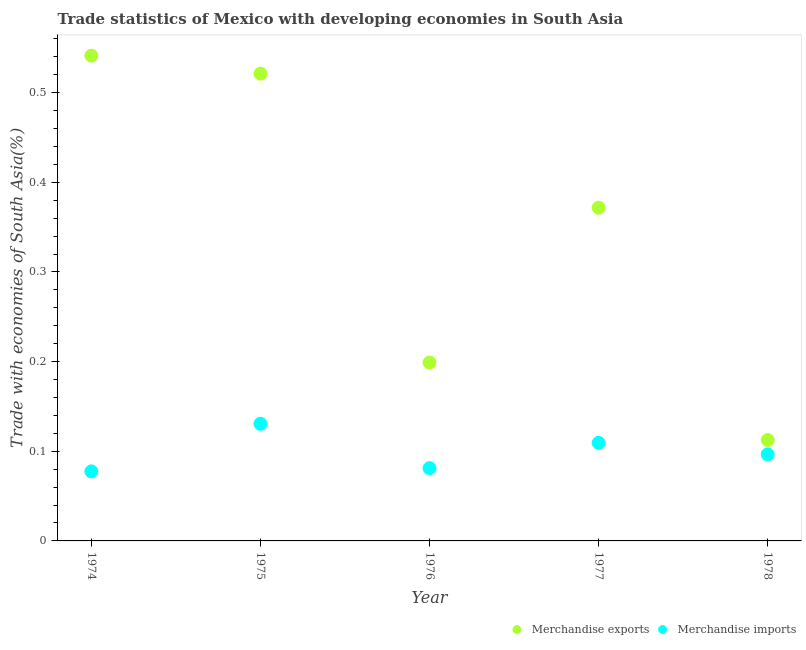How many different coloured dotlines are there?
Provide a succinct answer. 2. Is the number of dotlines equal to the number of legend labels?
Give a very brief answer. Yes. What is the merchandise exports in 1975?
Give a very brief answer. 0.52. Across all years, what is the maximum merchandise exports?
Provide a short and direct response. 0.54. Across all years, what is the minimum merchandise exports?
Provide a succinct answer. 0.11. In which year was the merchandise imports maximum?
Provide a succinct answer. 1975. In which year was the merchandise exports minimum?
Provide a short and direct response. 1978. What is the total merchandise imports in the graph?
Offer a terse response. 0.5. What is the difference between the merchandise exports in 1975 and that in 1977?
Ensure brevity in your answer.  0.15. What is the difference between the merchandise imports in 1978 and the merchandise exports in 1977?
Your answer should be compact. -0.28. What is the average merchandise imports per year?
Make the answer very short. 0.1. In the year 1974, what is the difference between the merchandise exports and merchandise imports?
Offer a terse response. 0.46. What is the ratio of the merchandise imports in 1974 to that in 1977?
Offer a very short reply. 0.71. Is the difference between the merchandise imports in 1974 and 1978 greater than the difference between the merchandise exports in 1974 and 1978?
Your response must be concise. No. What is the difference between the highest and the second highest merchandise imports?
Your answer should be very brief. 0.02. What is the difference between the highest and the lowest merchandise exports?
Provide a short and direct response. 0.43. In how many years, is the merchandise exports greater than the average merchandise exports taken over all years?
Keep it short and to the point. 3. Is the merchandise imports strictly less than the merchandise exports over the years?
Give a very brief answer. Yes. How many dotlines are there?
Make the answer very short. 2. What is the difference between two consecutive major ticks on the Y-axis?
Offer a terse response. 0.1. Does the graph contain any zero values?
Keep it short and to the point. No. Where does the legend appear in the graph?
Offer a very short reply. Bottom right. How are the legend labels stacked?
Your answer should be very brief. Horizontal. What is the title of the graph?
Provide a succinct answer. Trade statistics of Mexico with developing economies in South Asia. What is the label or title of the X-axis?
Keep it short and to the point. Year. What is the label or title of the Y-axis?
Offer a terse response. Trade with economies of South Asia(%). What is the Trade with economies of South Asia(%) in Merchandise exports in 1974?
Make the answer very short. 0.54. What is the Trade with economies of South Asia(%) of Merchandise imports in 1974?
Provide a short and direct response. 0.08. What is the Trade with economies of South Asia(%) in Merchandise exports in 1975?
Give a very brief answer. 0.52. What is the Trade with economies of South Asia(%) in Merchandise imports in 1975?
Keep it short and to the point. 0.13. What is the Trade with economies of South Asia(%) of Merchandise exports in 1976?
Provide a short and direct response. 0.2. What is the Trade with economies of South Asia(%) of Merchandise imports in 1976?
Provide a short and direct response. 0.08. What is the Trade with economies of South Asia(%) in Merchandise exports in 1977?
Provide a short and direct response. 0.37. What is the Trade with economies of South Asia(%) of Merchandise imports in 1977?
Ensure brevity in your answer.  0.11. What is the Trade with economies of South Asia(%) of Merchandise exports in 1978?
Provide a succinct answer. 0.11. What is the Trade with economies of South Asia(%) in Merchandise imports in 1978?
Make the answer very short. 0.1. Across all years, what is the maximum Trade with economies of South Asia(%) in Merchandise exports?
Your response must be concise. 0.54. Across all years, what is the maximum Trade with economies of South Asia(%) of Merchandise imports?
Offer a terse response. 0.13. Across all years, what is the minimum Trade with economies of South Asia(%) in Merchandise exports?
Your response must be concise. 0.11. Across all years, what is the minimum Trade with economies of South Asia(%) of Merchandise imports?
Your response must be concise. 0.08. What is the total Trade with economies of South Asia(%) in Merchandise exports in the graph?
Your answer should be very brief. 1.75. What is the total Trade with economies of South Asia(%) in Merchandise imports in the graph?
Provide a succinct answer. 0.5. What is the difference between the Trade with economies of South Asia(%) of Merchandise exports in 1974 and that in 1975?
Your response must be concise. 0.02. What is the difference between the Trade with economies of South Asia(%) of Merchandise imports in 1974 and that in 1975?
Ensure brevity in your answer.  -0.05. What is the difference between the Trade with economies of South Asia(%) in Merchandise exports in 1974 and that in 1976?
Offer a terse response. 0.34. What is the difference between the Trade with economies of South Asia(%) of Merchandise imports in 1974 and that in 1976?
Your answer should be very brief. -0. What is the difference between the Trade with economies of South Asia(%) in Merchandise exports in 1974 and that in 1977?
Make the answer very short. 0.17. What is the difference between the Trade with economies of South Asia(%) of Merchandise imports in 1974 and that in 1977?
Keep it short and to the point. -0.03. What is the difference between the Trade with economies of South Asia(%) in Merchandise exports in 1974 and that in 1978?
Keep it short and to the point. 0.43. What is the difference between the Trade with economies of South Asia(%) in Merchandise imports in 1974 and that in 1978?
Make the answer very short. -0.02. What is the difference between the Trade with economies of South Asia(%) of Merchandise exports in 1975 and that in 1976?
Make the answer very short. 0.32. What is the difference between the Trade with economies of South Asia(%) of Merchandise imports in 1975 and that in 1976?
Provide a short and direct response. 0.05. What is the difference between the Trade with economies of South Asia(%) of Merchandise exports in 1975 and that in 1977?
Your response must be concise. 0.15. What is the difference between the Trade with economies of South Asia(%) of Merchandise imports in 1975 and that in 1977?
Offer a very short reply. 0.02. What is the difference between the Trade with economies of South Asia(%) in Merchandise exports in 1975 and that in 1978?
Keep it short and to the point. 0.41. What is the difference between the Trade with economies of South Asia(%) of Merchandise imports in 1975 and that in 1978?
Make the answer very short. 0.03. What is the difference between the Trade with economies of South Asia(%) of Merchandise exports in 1976 and that in 1977?
Give a very brief answer. -0.17. What is the difference between the Trade with economies of South Asia(%) in Merchandise imports in 1976 and that in 1977?
Offer a very short reply. -0.03. What is the difference between the Trade with economies of South Asia(%) of Merchandise exports in 1976 and that in 1978?
Your answer should be very brief. 0.09. What is the difference between the Trade with economies of South Asia(%) in Merchandise imports in 1976 and that in 1978?
Offer a terse response. -0.02. What is the difference between the Trade with economies of South Asia(%) of Merchandise exports in 1977 and that in 1978?
Your response must be concise. 0.26. What is the difference between the Trade with economies of South Asia(%) in Merchandise imports in 1977 and that in 1978?
Give a very brief answer. 0.01. What is the difference between the Trade with economies of South Asia(%) of Merchandise exports in 1974 and the Trade with economies of South Asia(%) of Merchandise imports in 1975?
Give a very brief answer. 0.41. What is the difference between the Trade with economies of South Asia(%) of Merchandise exports in 1974 and the Trade with economies of South Asia(%) of Merchandise imports in 1976?
Your answer should be compact. 0.46. What is the difference between the Trade with economies of South Asia(%) of Merchandise exports in 1974 and the Trade with economies of South Asia(%) of Merchandise imports in 1977?
Ensure brevity in your answer.  0.43. What is the difference between the Trade with economies of South Asia(%) in Merchandise exports in 1974 and the Trade with economies of South Asia(%) in Merchandise imports in 1978?
Offer a very short reply. 0.44. What is the difference between the Trade with economies of South Asia(%) of Merchandise exports in 1975 and the Trade with economies of South Asia(%) of Merchandise imports in 1976?
Your answer should be compact. 0.44. What is the difference between the Trade with economies of South Asia(%) in Merchandise exports in 1975 and the Trade with economies of South Asia(%) in Merchandise imports in 1977?
Offer a very short reply. 0.41. What is the difference between the Trade with economies of South Asia(%) in Merchandise exports in 1975 and the Trade with economies of South Asia(%) in Merchandise imports in 1978?
Offer a terse response. 0.42. What is the difference between the Trade with economies of South Asia(%) in Merchandise exports in 1976 and the Trade with economies of South Asia(%) in Merchandise imports in 1977?
Your answer should be very brief. 0.09. What is the difference between the Trade with economies of South Asia(%) in Merchandise exports in 1976 and the Trade with economies of South Asia(%) in Merchandise imports in 1978?
Offer a terse response. 0.1. What is the difference between the Trade with economies of South Asia(%) of Merchandise exports in 1977 and the Trade with economies of South Asia(%) of Merchandise imports in 1978?
Keep it short and to the point. 0.28. What is the average Trade with economies of South Asia(%) of Merchandise exports per year?
Make the answer very short. 0.35. What is the average Trade with economies of South Asia(%) of Merchandise imports per year?
Your response must be concise. 0.1. In the year 1974, what is the difference between the Trade with economies of South Asia(%) of Merchandise exports and Trade with economies of South Asia(%) of Merchandise imports?
Make the answer very short. 0.46. In the year 1975, what is the difference between the Trade with economies of South Asia(%) of Merchandise exports and Trade with economies of South Asia(%) of Merchandise imports?
Offer a terse response. 0.39. In the year 1976, what is the difference between the Trade with economies of South Asia(%) of Merchandise exports and Trade with economies of South Asia(%) of Merchandise imports?
Provide a succinct answer. 0.12. In the year 1977, what is the difference between the Trade with economies of South Asia(%) in Merchandise exports and Trade with economies of South Asia(%) in Merchandise imports?
Make the answer very short. 0.26. In the year 1978, what is the difference between the Trade with economies of South Asia(%) in Merchandise exports and Trade with economies of South Asia(%) in Merchandise imports?
Your answer should be very brief. 0.02. What is the ratio of the Trade with economies of South Asia(%) of Merchandise exports in 1974 to that in 1975?
Provide a succinct answer. 1.04. What is the ratio of the Trade with economies of South Asia(%) in Merchandise imports in 1974 to that in 1975?
Your answer should be compact. 0.59. What is the ratio of the Trade with economies of South Asia(%) in Merchandise exports in 1974 to that in 1976?
Make the answer very short. 2.72. What is the ratio of the Trade with economies of South Asia(%) of Merchandise imports in 1974 to that in 1976?
Offer a very short reply. 0.96. What is the ratio of the Trade with economies of South Asia(%) of Merchandise exports in 1974 to that in 1977?
Provide a succinct answer. 1.46. What is the ratio of the Trade with economies of South Asia(%) of Merchandise imports in 1974 to that in 1977?
Ensure brevity in your answer.  0.71. What is the ratio of the Trade with economies of South Asia(%) of Merchandise exports in 1974 to that in 1978?
Keep it short and to the point. 4.81. What is the ratio of the Trade with economies of South Asia(%) of Merchandise imports in 1974 to that in 1978?
Offer a terse response. 0.8. What is the ratio of the Trade with economies of South Asia(%) of Merchandise exports in 1975 to that in 1976?
Provide a short and direct response. 2.62. What is the ratio of the Trade with economies of South Asia(%) in Merchandise imports in 1975 to that in 1976?
Keep it short and to the point. 1.61. What is the ratio of the Trade with economies of South Asia(%) in Merchandise exports in 1975 to that in 1977?
Provide a succinct answer. 1.4. What is the ratio of the Trade with economies of South Asia(%) in Merchandise imports in 1975 to that in 1977?
Ensure brevity in your answer.  1.19. What is the ratio of the Trade with economies of South Asia(%) in Merchandise exports in 1975 to that in 1978?
Offer a terse response. 4.63. What is the ratio of the Trade with economies of South Asia(%) in Merchandise imports in 1975 to that in 1978?
Your answer should be very brief. 1.35. What is the ratio of the Trade with economies of South Asia(%) in Merchandise exports in 1976 to that in 1977?
Your answer should be very brief. 0.54. What is the ratio of the Trade with economies of South Asia(%) of Merchandise imports in 1976 to that in 1977?
Your answer should be very brief. 0.74. What is the ratio of the Trade with economies of South Asia(%) of Merchandise exports in 1976 to that in 1978?
Your response must be concise. 1.77. What is the ratio of the Trade with economies of South Asia(%) in Merchandise imports in 1976 to that in 1978?
Offer a terse response. 0.84. What is the ratio of the Trade with economies of South Asia(%) of Merchandise exports in 1977 to that in 1978?
Make the answer very short. 3.3. What is the ratio of the Trade with economies of South Asia(%) of Merchandise imports in 1977 to that in 1978?
Your answer should be very brief. 1.13. What is the difference between the highest and the second highest Trade with economies of South Asia(%) in Merchandise exports?
Offer a very short reply. 0.02. What is the difference between the highest and the second highest Trade with economies of South Asia(%) in Merchandise imports?
Give a very brief answer. 0.02. What is the difference between the highest and the lowest Trade with economies of South Asia(%) in Merchandise exports?
Your answer should be compact. 0.43. What is the difference between the highest and the lowest Trade with economies of South Asia(%) in Merchandise imports?
Provide a short and direct response. 0.05. 